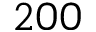<formula> <loc_0><loc_0><loc_500><loc_500>2 0 0</formula> 